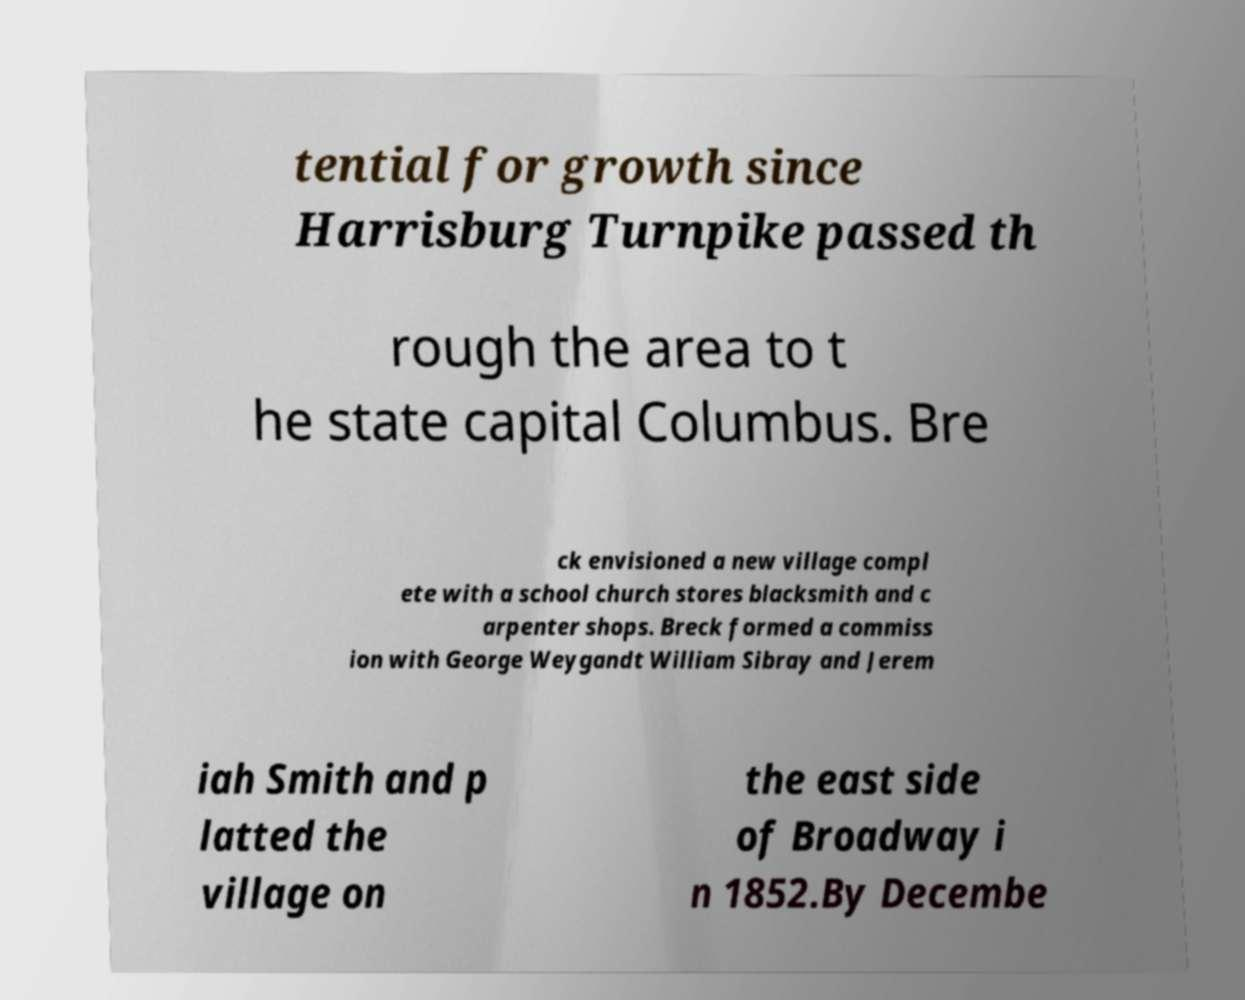Could you assist in decoding the text presented in this image and type it out clearly? tential for growth since Harrisburg Turnpike passed th rough the area to t he state capital Columbus. Bre ck envisioned a new village compl ete with a school church stores blacksmith and c arpenter shops. Breck formed a commiss ion with George Weygandt William Sibray and Jerem iah Smith and p latted the village on the east side of Broadway i n 1852.By Decembe 